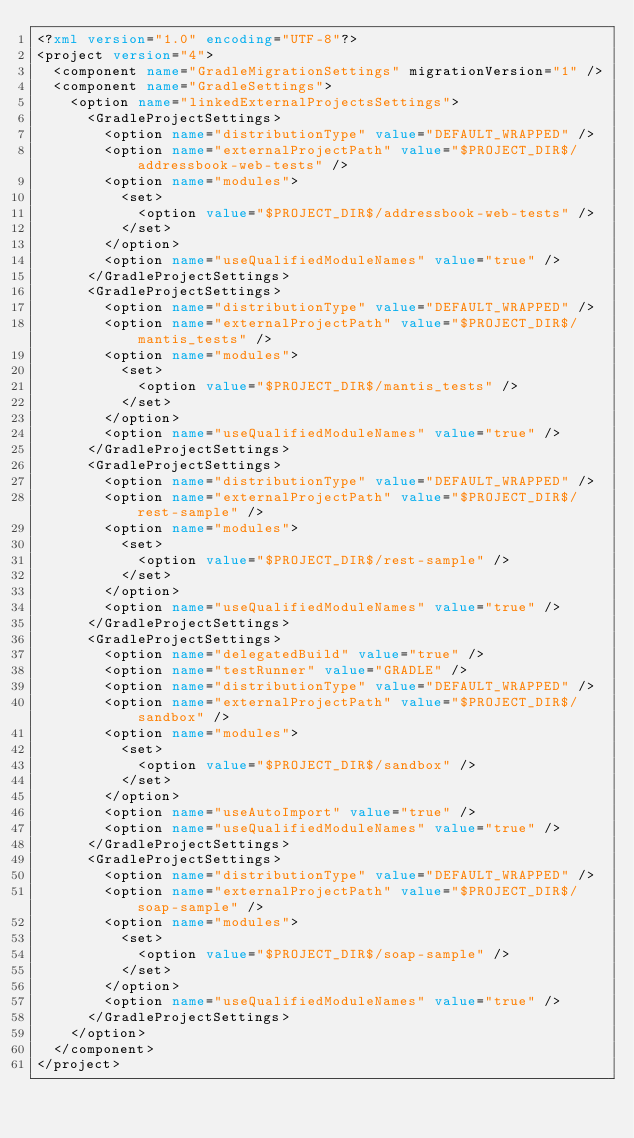Convert code to text. <code><loc_0><loc_0><loc_500><loc_500><_XML_><?xml version="1.0" encoding="UTF-8"?>
<project version="4">
  <component name="GradleMigrationSettings" migrationVersion="1" />
  <component name="GradleSettings">
    <option name="linkedExternalProjectsSettings">
      <GradleProjectSettings>
        <option name="distributionType" value="DEFAULT_WRAPPED" />
        <option name="externalProjectPath" value="$PROJECT_DIR$/addressbook-web-tests" />
        <option name="modules">
          <set>
            <option value="$PROJECT_DIR$/addressbook-web-tests" />
          </set>
        </option>
        <option name="useQualifiedModuleNames" value="true" />
      </GradleProjectSettings>
      <GradleProjectSettings>
        <option name="distributionType" value="DEFAULT_WRAPPED" />
        <option name="externalProjectPath" value="$PROJECT_DIR$/mantis_tests" />
        <option name="modules">
          <set>
            <option value="$PROJECT_DIR$/mantis_tests" />
          </set>
        </option>
        <option name="useQualifiedModuleNames" value="true" />
      </GradleProjectSettings>
      <GradleProjectSettings>
        <option name="distributionType" value="DEFAULT_WRAPPED" />
        <option name="externalProjectPath" value="$PROJECT_DIR$/rest-sample" />
        <option name="modules">
          <set>
            <option value="$PROJECT_DIR$/rest-sample" />
          </set>
        </option>
        <option name="useQualifiedModuleNames" value="true" />
      </GradleProjectSettings>
      <GradleProjectSettings>
        <option name="delegatedBuild" value="true" />
        <option name="testRunner" value="GRADLE" />
        <option name="distributionType" value="DEFAULT_WRAPPED" />
        <option name="externalProjectPath" value="$PROJECT_DIR$/sandbox" />
        <option name="modules">
          <set>
            <option value="$PROJECT_DIR$/sandbox" />
          </set>
        </option>
        <option name="useAutoImport" value="true" />
        <option name="useQualifiedModuleNames" value="true" />
      </GradleProjectSettings>
      <GradleProjectSettings>
        <option name="distributionType" value="DEFAULT_WRAPPED" />
        <option name="externalProjectPath" value="$PROJECT_DIR$/soap-sample" />
        <option name="modules">
          <set>
            <option value="$PROJECT_DIR$/soap-sample" />
          </set>
        </option>
        <option name="useQualifiedModuleNames" value="true" />
      </GradleProjectSettings>
    </option>
  </component>
</project></code> 